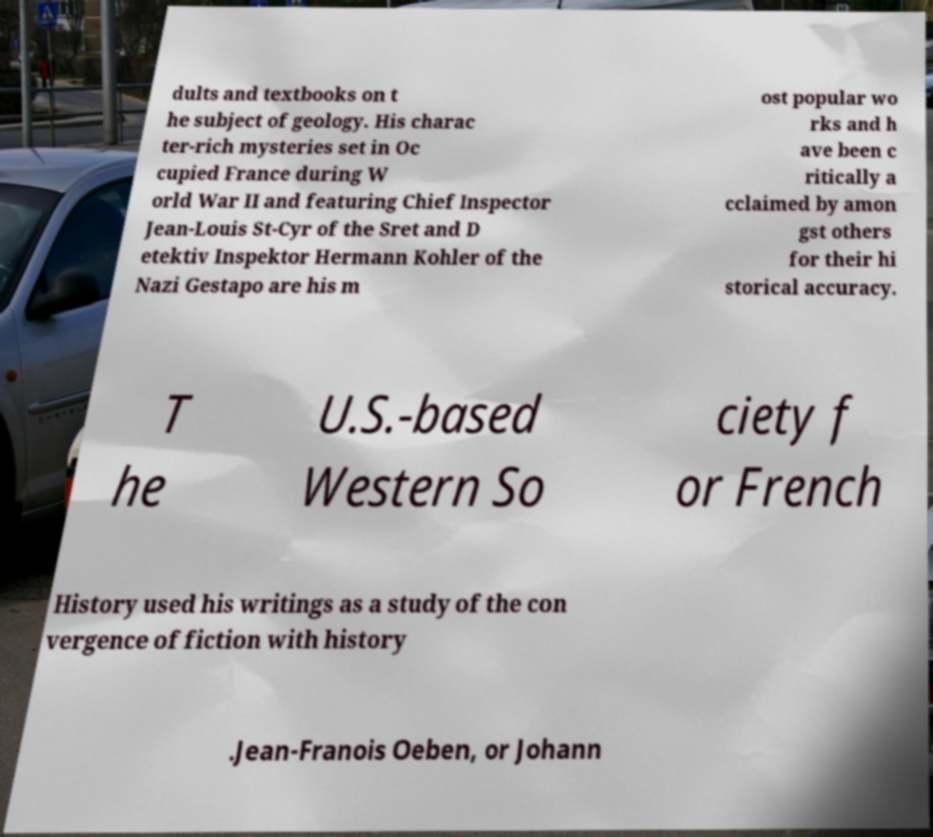Please read and relay the text visible in this image. What does it say? dults and textbooks on t he subject of geology. His charac ter-rich mysteries set in Oc cupied France during W orld War II and featuring Chief Inspector Jean-Louis St-Cyr of the Sret and D etektiv Inspektor Hermann Kohler of the Nazi Gestapo are his m ost popular wo rks and h ave been c ritically a cclaimed by amon gst others for their hi storical accuracy. T he U.S.-based Western So ciety f or French History used his writings as a study of the con vergence of fiction with history .Jean-Franois Oeben, or Johann 